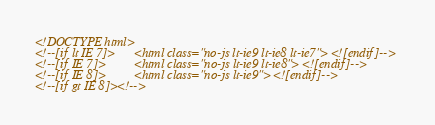Convert code to text. <code><loc_0><loc_0><loc_500><loc_500><_HTML_><!DOCTYPE html>
<!--[if lt IE 7]>      <html class="no-js lt-ie9 lt-ie8 lt-ie7"> <![endif]-->
<!--[if IE 7]>         <html class="no-js lt-ie9 lt-ie8"> <![endif]-->
<!--[if IE 8]>         <html class="no-js lt-ie9"> <![endif]-->
<!--[if gt IE 8]><!--></code> 